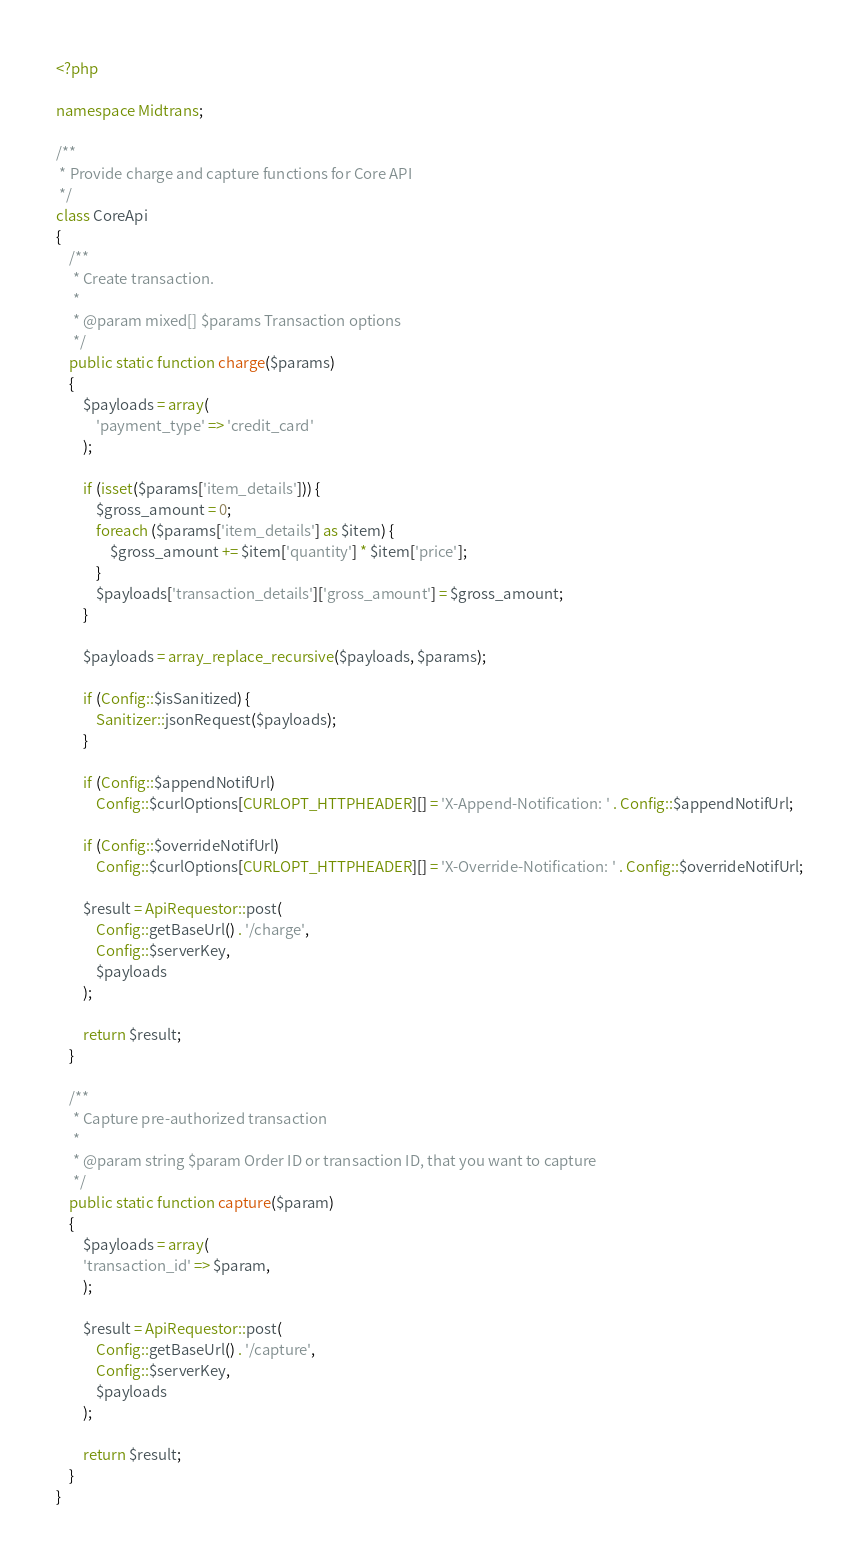Convert code to text. <code><loc_0><loc_0><loc_500><loc_500><_PHP_><?php

namespace Midtrans;

/**
 * Provide charge and capture functions for Core API
 */
class CoreApi
{
    /**
     * Create transaction.
     *
     * @param mixed[] $params Transaction options
     */
    public static function charge($params)
    {
        $payloads = array(
            'payment_type' => 'credit_card'
        );

        if (isset($params['item_details'])) {
            $gross_amount = 0;
            foreach ($params['item_details'] as $item) {
                $gross_amount += $item['quantity'] * $item['price'];
            }
            $payloads['transaction_details']['gross_amount'] = $gross_amount;
        }

        $payloads = array_replace_recursive($payloads, $params);

        if (Config::$isSanitized) {
            Sanitizer::jsonRequest($payloads);
        }

        if (Config::$appendNotifUrl)
            Config::$curlOptions[CURLOPT_HTTPHEADER][] = 'X-Append-Notification: ' . Config::$appendNotifUrl;

        if (Config::$overrideNotifUrl)
            Config::$curlOptions[CURLOPT_HTTPHEADER][] = 'X-Override-Notification: ' . Config::$overrideNotifUrl;

        $result = ApiRequestor::post(
            Config::getBaseUrl() . '/charge',
            Config::$serverKey,
            $payloads
        );

        return $result;
    }

    /**
     * Capture pre-authorized transaction
     *
     * @param string $param Order ID or transaction ID, that you want to capture
     */
    public static function capture($param)
    {
        $payloads = array(
        'transaction_id' => $param,
        );

        $result = ApiRequestor::post(
            Config::getBaseUrl() . '/capture',
            Config::$serverKey,
            $payloads
        );

        return $result;
    }
}
</code> 